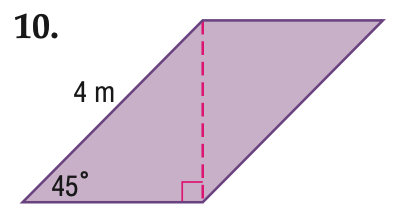Answer the mathemtical geometry problem and directly provide the correct option letter.
Question: Find the area of the parallelogram. Round to the nearest tenth if necessary.
Choices: A: 4 B: 8 C: 12 D: 16 B 